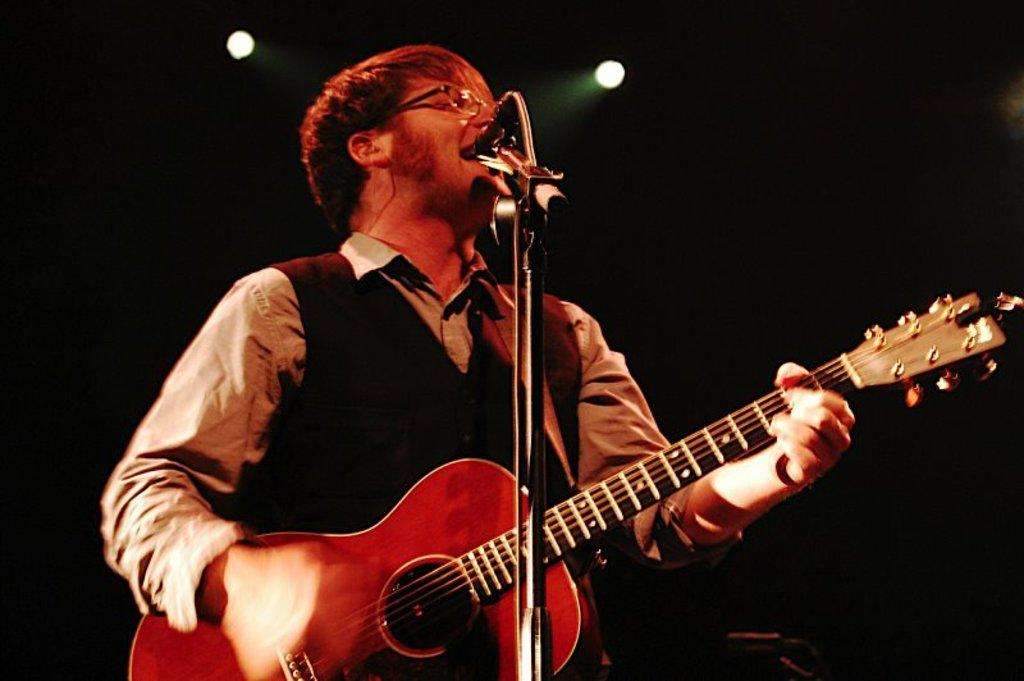What is the man in the image doing? The man is playing guitar in the image. How is the man playing the guitar? The man is using his hands to play the guitar. Is the man singing in the image? Yes, the man is singing on a microphone. What can be seen on the man's face in the image? The man is wearing spectacles. What can be seen in the background of the image? There is a light visible in the image. What is the man's opinion on the building in the image? There is no building present in the image, so it is not possible to determine the man's opinion on a building. 